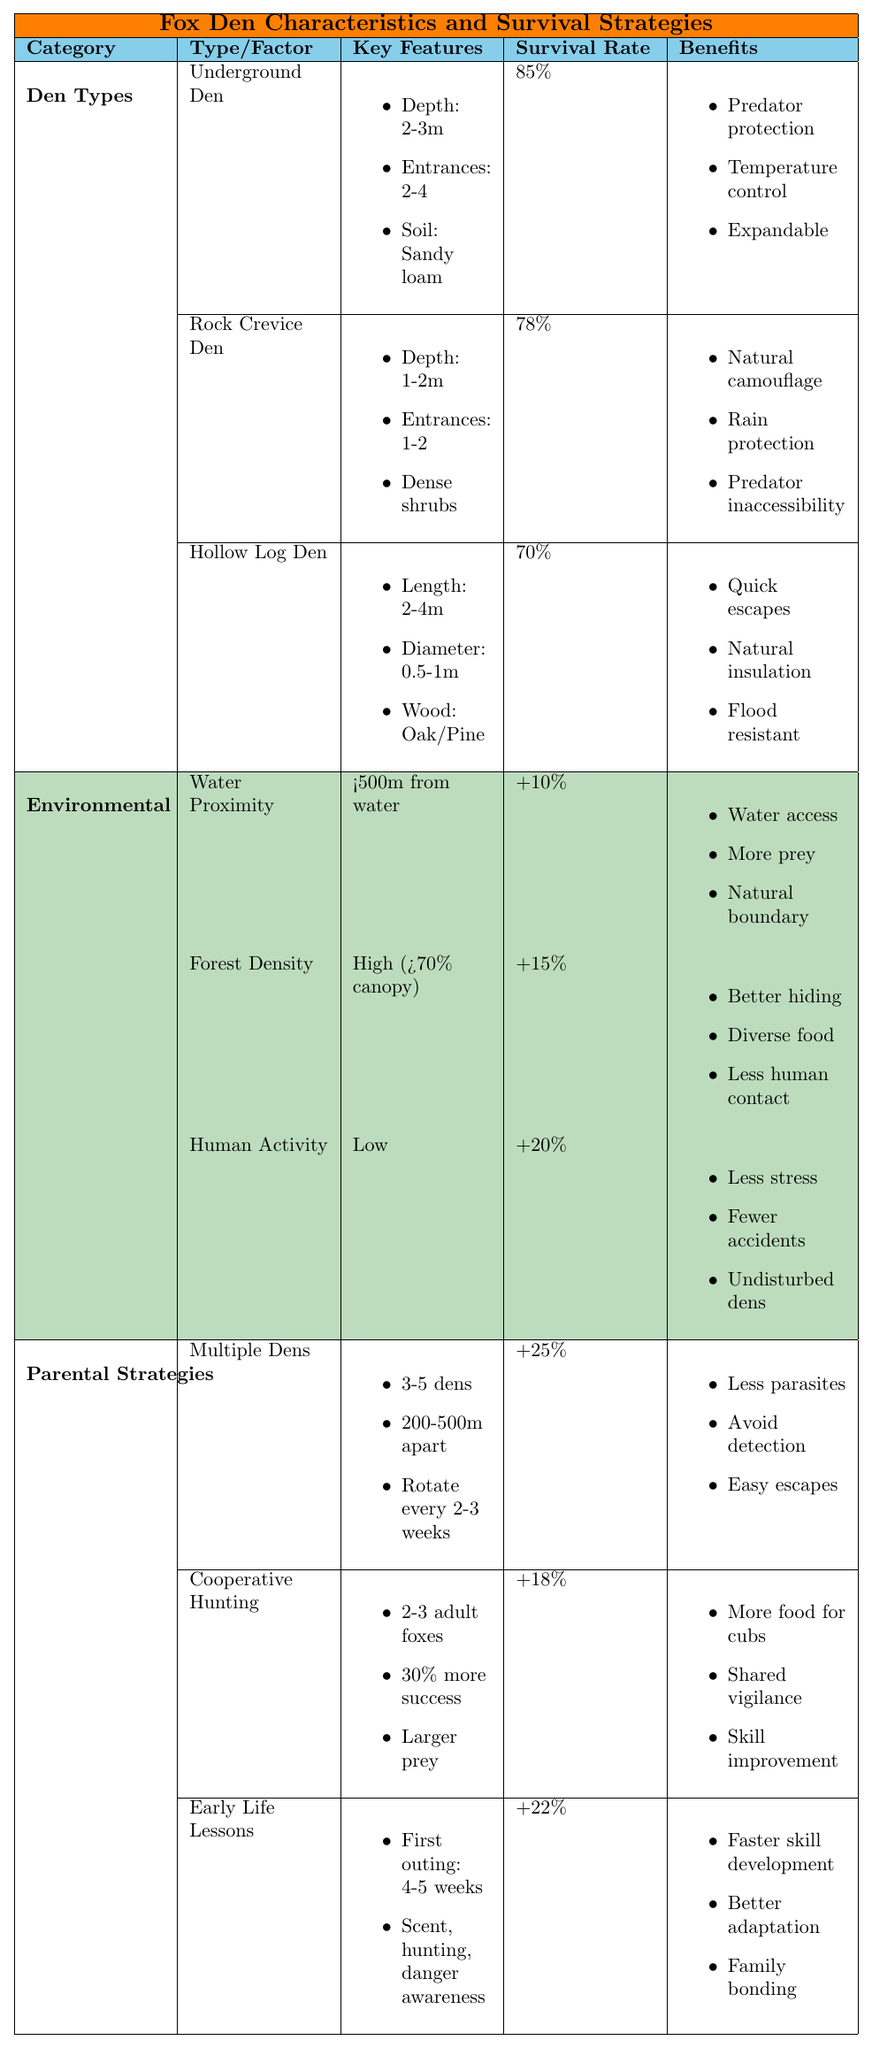What is the family survival rate for Underground Dens? The table lists the family survival rate for Underground Dens as 85%.
Answer: 85% Which type of den has the lowest family survival rate? The Hollow Log Den has the lowest family survival rate at 70%.
Answer: Hollow Log Den What increase in survival rate does a low level of human activity provide? The table shows that low human activity increases the survival rate by 20%.
Answer: 20% How many entrances do Rock Crevice Dens typically have? According to the table, Rock Crevice Dens typically have 1-2 entrances.
Answer: 1-2 If a fox family uses Multiple Dens, what is the survival rate increase? The survival rate increases by 25% when using Multiple Dens.
Answer: 25% What are the benefits of having a den located less than 500 meters from water? Benefits include easy access to drinking water, increased prey availability, and a natural boundary against some predators.
Answer: Three benefits Which den type provides natural camouflage? The Rock Crevice Den provides natural camouflage.
Answer: Rock Crevice Den What is the difference in survival rates between Underground Dens and Hollow Log Dens? The difference is calculated as 85% (Underground) - 70% (Hollow Log) = 15%.
Answer: 15% Does having high forest density positively impact survival rates? Yes, high forest density increases survival rates by 15%.
Answer: Yes How does cooperative hunting affect the survival rate? Cooperative hunting increases the survival rate by 18%.
Answer: 18% What is the combined increase in survival rate from using Multiple Dens and having low human activity? The combined increase is 25% (Multiple Dens) + 20% (Low Human Activity) = 45%.
Answer: 45% 